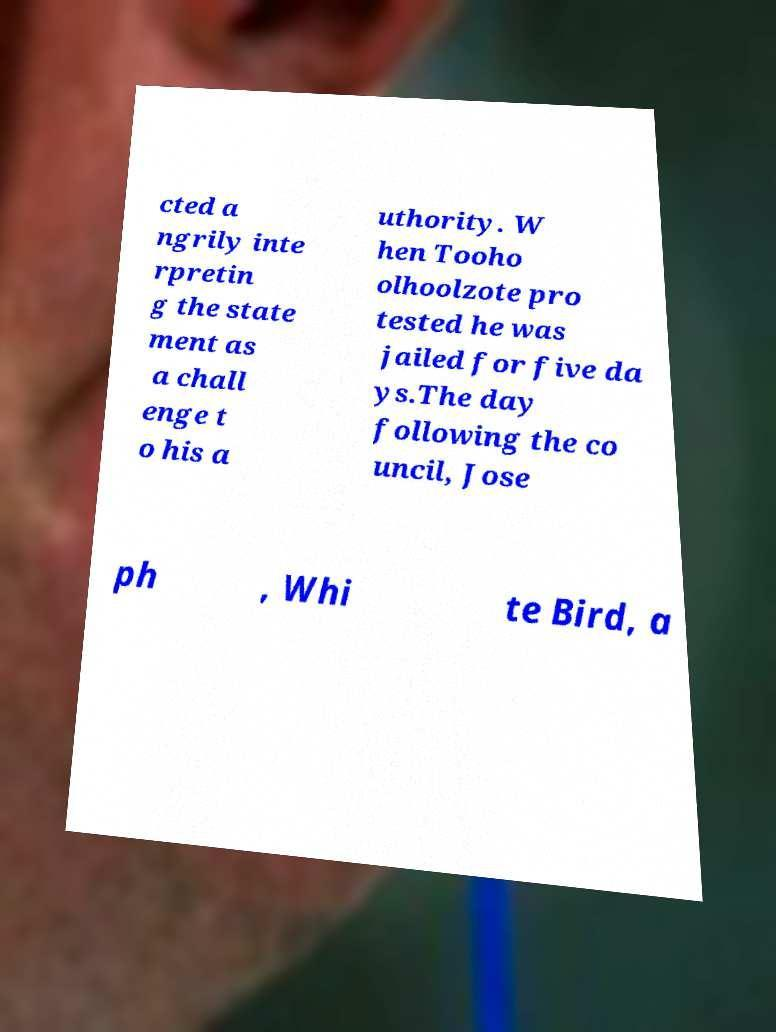I need the written content from this picture converted into text. Can you do that? cted a ngrily inte rpretin g the state ment as a chall enge t o his a uthority. W hen Tooho olhoolzote pro tested he was jailed for five da ys.The day following the co uncil, Jose ph , Whi te Bird, a 